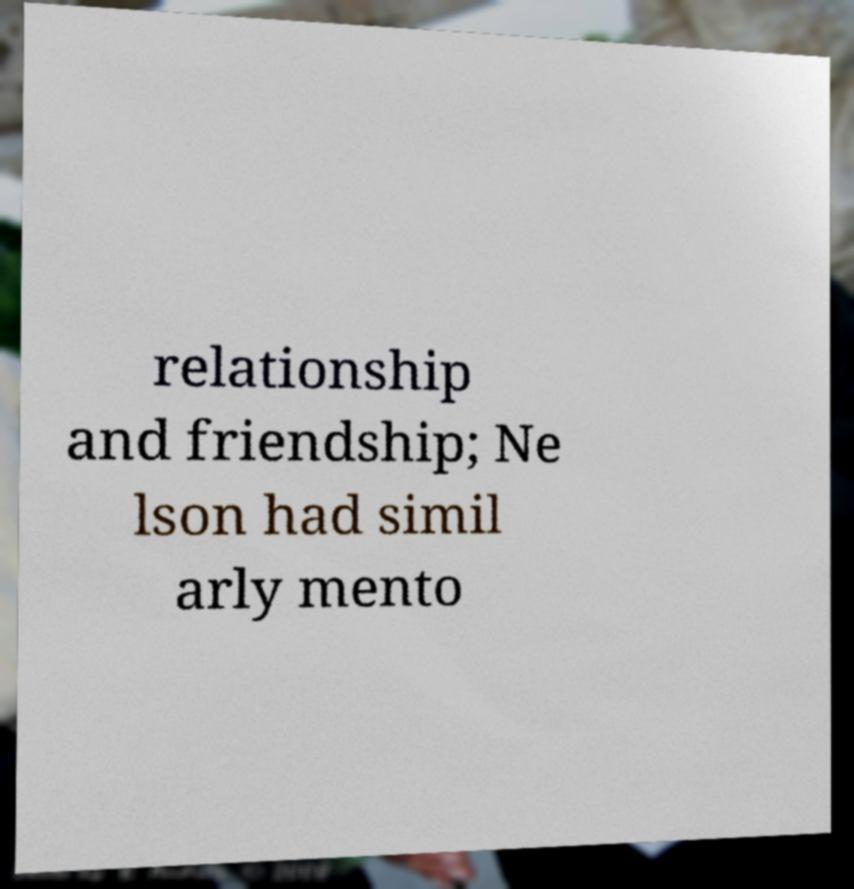Can you read and provide the text displayed in the image?This photo seems to have some interesting text. Can you extract and type it out for me? relationship and friendship; Ne lson had simil arly mento 